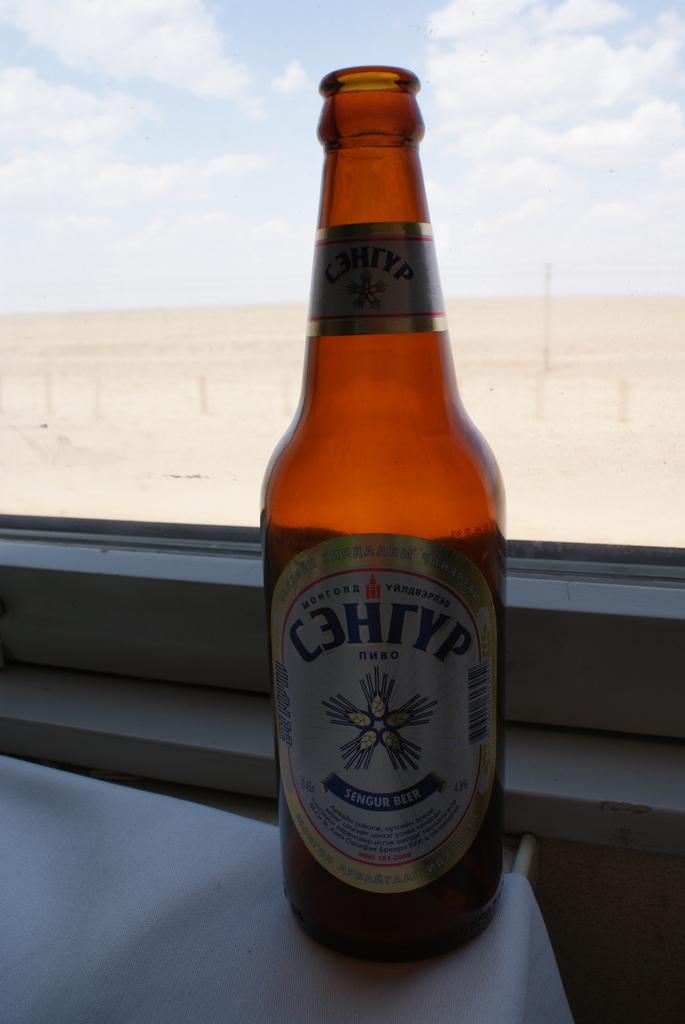What is the name of this beer?
Provide a short and direct response. Unanswerable. 